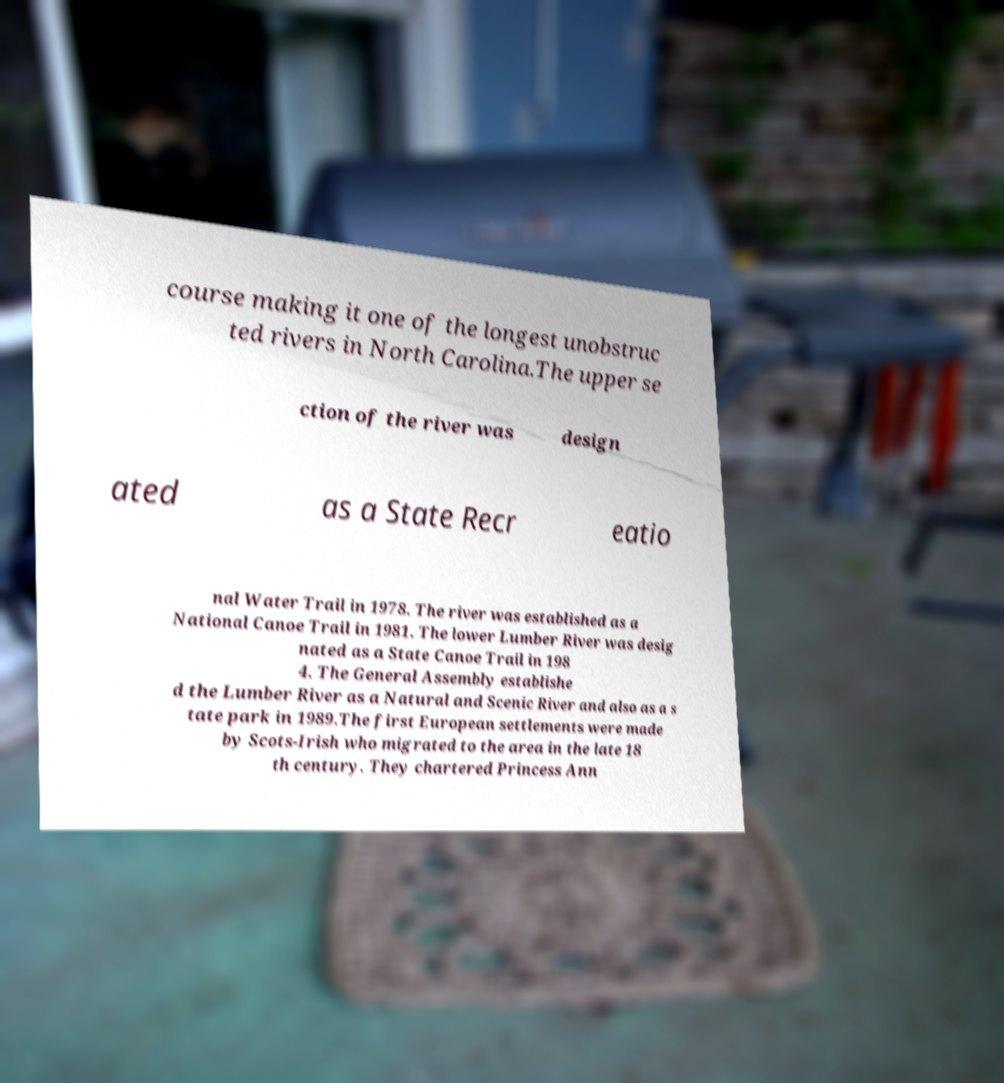For documentation purposes, I need the text within this image transcribed. Could you provide that? course making it one of the longest unobstruc ted rivers in North Carolina.The upper se ction of the river was design ated as a State Recr eatio nal Water Trail in 1978. The river was established as a National Canoe Trail in 1981. The lower Lumber River was desig nated as a State Canoe Trail in 198 4. The General Assembly establishe d the Lumber River as a Natural and Scenic River and also as a s tate park in 1989.The first European settlements were made by Scots-Irish who migrated to the area in the late 18 th century. They chartered Princess Ann 